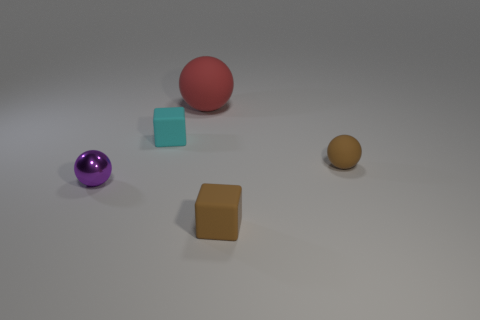Is there any other thing that is the same size as the red matte sphere?
Ensure brevity in your answer.  No. There is a ball that is both to the left of the brown rubber block and to the right of the tiny metallic ball; what is its size?
Ensure brevity in your answer.  Large. What shape is the thing to the left of the tiny cyan matte cube?
Provide a succinct answer. Sphere. Is the purple sphere made of the same material as the sphere on the right side of the big rubber ball?
Provide a short and direct response. No. Is the shape of the small purple metallic object the same as the large red matte thing?
Your answer should be compact. Yes. What is the material of the purple object that is the same shape as the red rubber thing?
Your response must be concise. Metal. What color is the ball that is in front of the red matte sphere and on the right side of the small purple metallic sphere?
Ensure brevity in your answer.  Brown. What color is the metallic thing?
Ensure brevity in your answer.  Purple. Is there a brown object of the same shape as the red object?
Offer a terse response. Yes. There is a block that is behind the tiny brown matte block; how big is it?
Ensure brevity in your answer.  Small. 